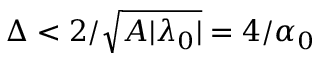<formula> <loc_0><loc_0><loc_500><loc_500>\Delta < 2 / \sqrt { A | \lambda _ { 0 } | } = 4 / \alpha _ { 0 }</formula> 